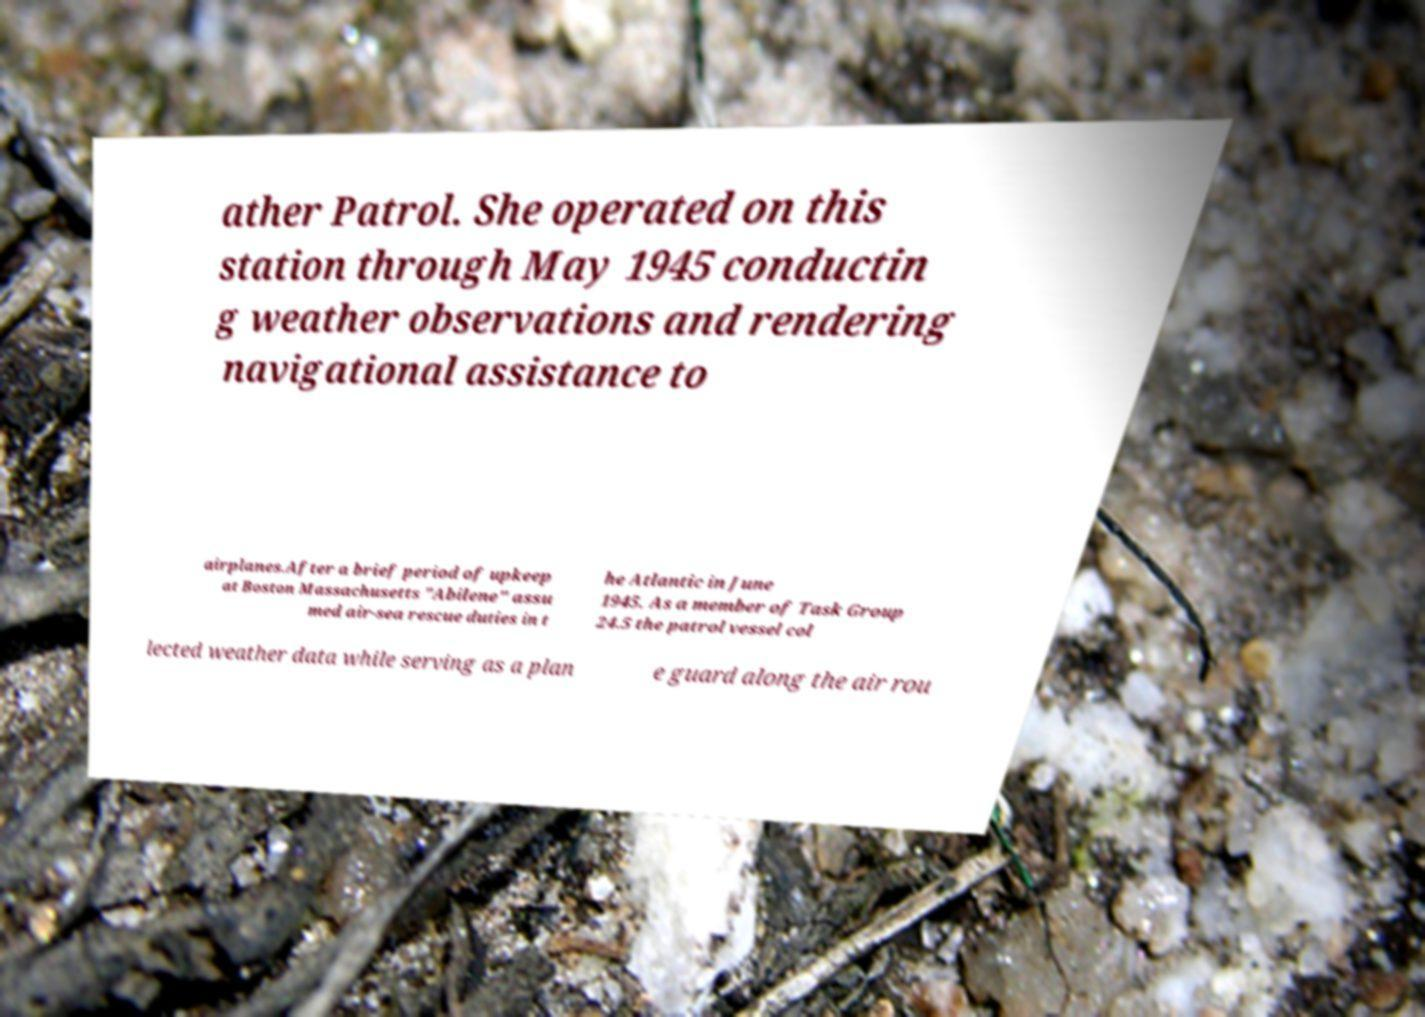I need the written content from this picture converted into text. Can you do that? ather Patrol. She operated on this station through May 1945 conductin g weather observations and rendering navigational assistance to airplanes.After a brief period of upkeep at Boston Massachusetts "Abilene" assu med air-sea rescue duties in t he Atlantic in June 1945. As a member of Task Group 24.5 the patrol vessel col lected weather data while serving as a plan e guard along the air rou 